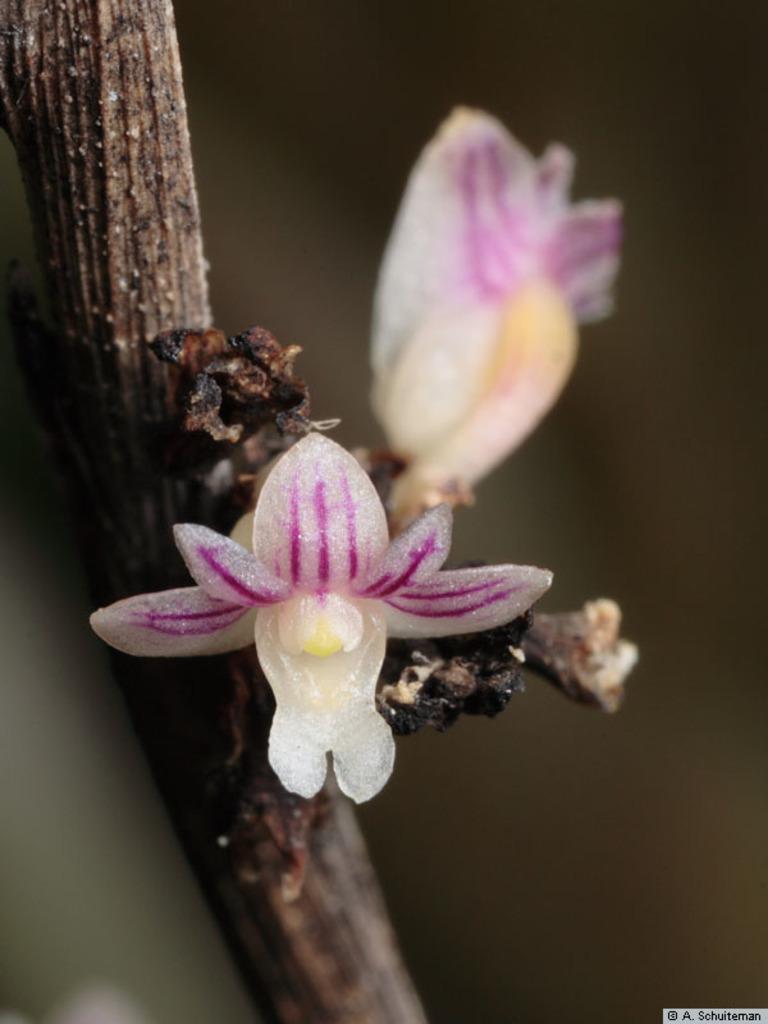How would you summarize this image in a sentence or two? In this image I can see a flower in white and pink color on the branch and I can see dark background. 